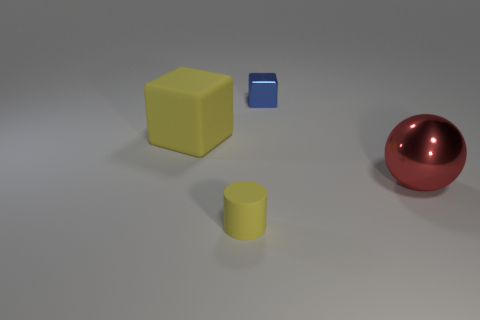Is the material of the block that is behind the yellow cube the same as the yellow cube?
Offer a terse response. No. Is the number of large objects that are to the right of the red shiny object greater than the number of tiny objects behind the big yellow object?
Offer a terse response. No. What is the material of the other object that is the same size as the blue shiny thing?
Provide a succinct answer. Rubber. What number of other objects are the same material as the red ball?
Keep it short and to the point. 1. Is the shape of the yellow rubber object that is on the left side of the tiny rubber thing the same as the yellow matte thing that is in front of the large red thing?
Offer a very short reply. No. How many other objects are there of the same color as the big ball?
Your response must be concise. 0. Is the tiny object that is in front of the large red sphere made of the same material as the cube behind the large yellow object?
Your answer should be very brief. No. Is the number of red things that are to the left of the matte cylinder the same as the number of yellow blocks left of the big yellow object?
Your answer should be compact. Yes. There is a tiny thing that is in front of the tiny blue metallic thing; what is its material?
Provide a short and direct response. Rubber. Are there fewer big things than things?
Your answer should be compact. Yes. 